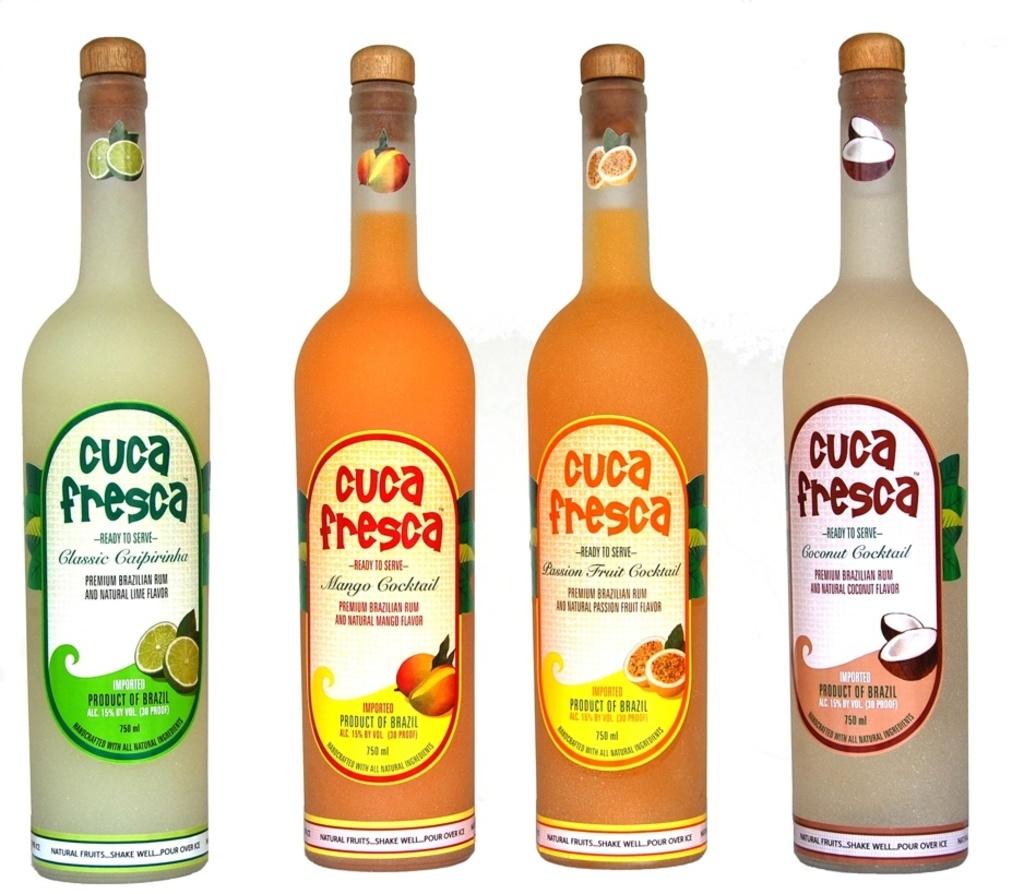Where was the rum made?
Make the answer very short. Brazil. 